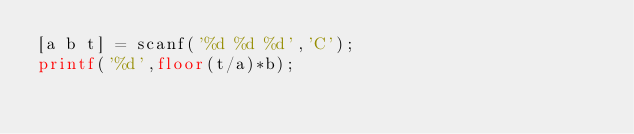Convert code to text. <code><loc_0><loc_0><loc_500><loc_500><_Octave_>[a b t] = scanf('%d %d %d','C');
printf('%d',floor(t/a)*b);</code> 